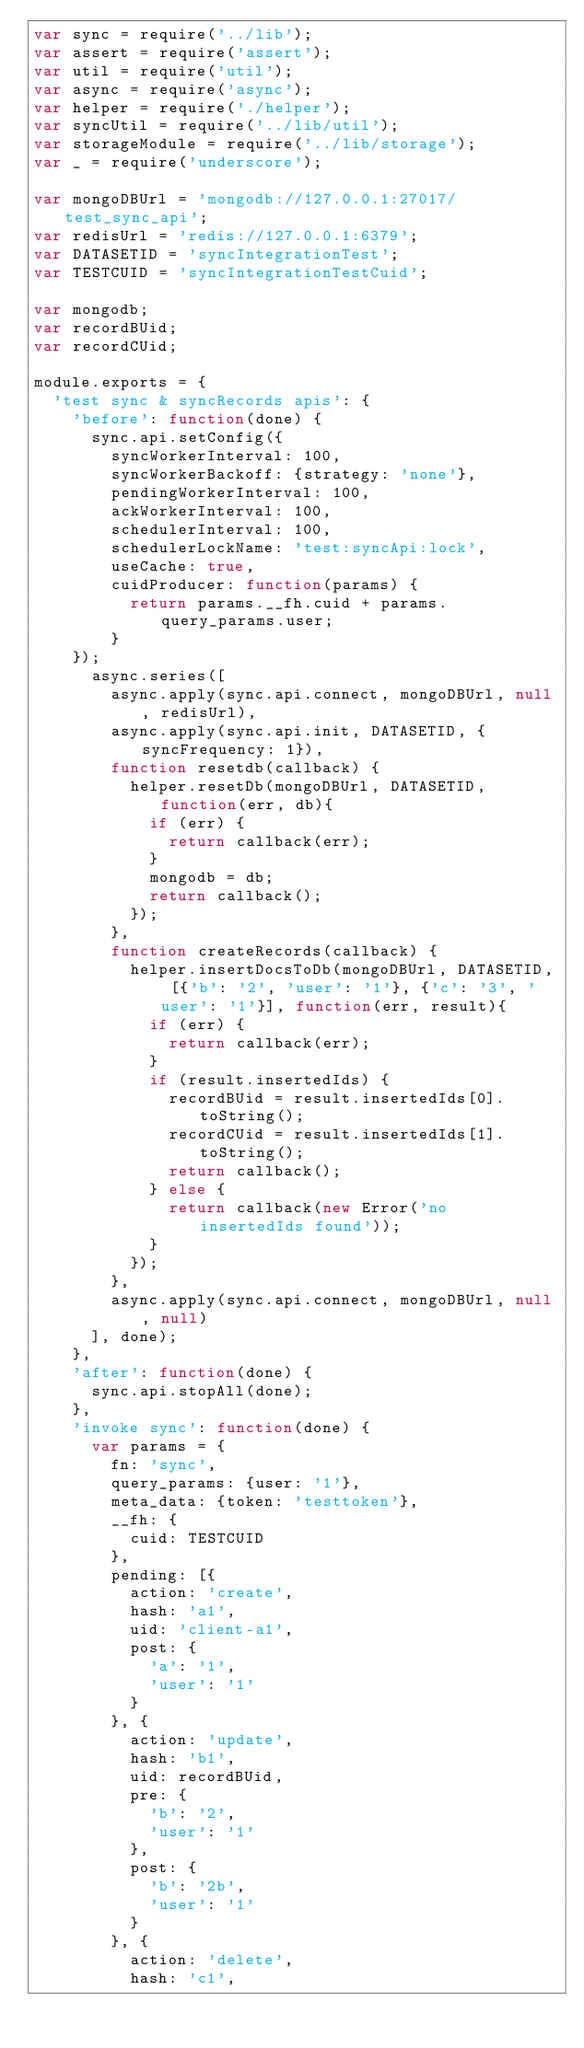Convert code to text. <code><loc_0><loc_0><loc_500><loc_500><_JavaScript_>var sync = require('../lib');
var assert = require('assert');
var util = require('util');
var async = require('async');
var helper = require('./helper');
var syncUtil = require('../lib/util');
var storageModule = require('../lib/storage');
var _ = require('underscore');

var mongoDBUrl = 'mongodb://127.0.0.1:27017/test_sync_api';
var redisUrl = 'redis://127.0.0.1:6379';
var DATASETID = 'syncIntegrationTest';
var TESTCUID = 'syncIntegrationTestCuid';

var mongodb;
var recordBUid;
var recordCUid;

module.exports = {
  'test sync & syncRecords apis': {
    'before': function(done) {
      sync.api.setConfig({
        syncWorkerInterval: 100, 
        syncWorkerBackoff: {strategy: 'none'},
        pendingWorkerInterval: 100, 
        ackWorkerInterval: 100, 
        schedulerInterval: 100, 
        schedulerLockName: 'test:syncApi:lock', 
        useCache: true,
        cuidProducer: function(params) {
          return params.__fh.cuid + params.query_params.user;
        }
    });
      async.series([
        async.apply(sync.api.connect, mongoDBUrl, null, redisUrl),
        async.apply(sync.api.init, DATASETID, {syncFrequency: 1}),
        function resetdb(callback) {
          helper.resetDb(mongoDBUrl, DATASETID, function(err, db){
            if (err) {
              return callback(err);
            }
            mongodb = db;
            return callback();
          });
        },
        function createRecords(callback) {
          helper.insertDocsToDb(mongoDBUrl, DATASETID, [{'b': '2', 'user': '1'}, {'c': '3', 'user': '1'}], function(err, result){
            if (err) {
              return callback(err);
            }
            if (result.insertedIds) {
              recordBUid = result.insertedIds[0].toString();
              recordCUid = result.insertedIds[1].toString();
              return callback();
            } else {
              return callback(new Error('no insertedIds found'));
            }
          });
        },
        async.apply(sync.api.connect, mongoDBUrl, null, null)
      ], done);
    },
    'after': function(done) {
      sync.api.stopAll(done);
    },
    'invoke sync': function(done) {
      var params = {
        fn: 'sync',
        query_params: {user: '1'},
        meta_data: {token: 'testtoken'},
        __fh: {
          cuid: TESTCUID
        },
        pending: [{
          action: 'create',
          hash: 'a1',
          uid: 'client-a1',
          post: {
            'a': '1',
            'user': '1'
          }
        }, {
          action: 'update',
          hash: 'b1',
          uid: recordBUid,
          pre: {
            'b': '2',
            'user': '1'
          },
          post: {
            'b': '2b',
            'user': '1'
          }
        }, {
          action: 'delete',
          hash: 'c1',</code> 